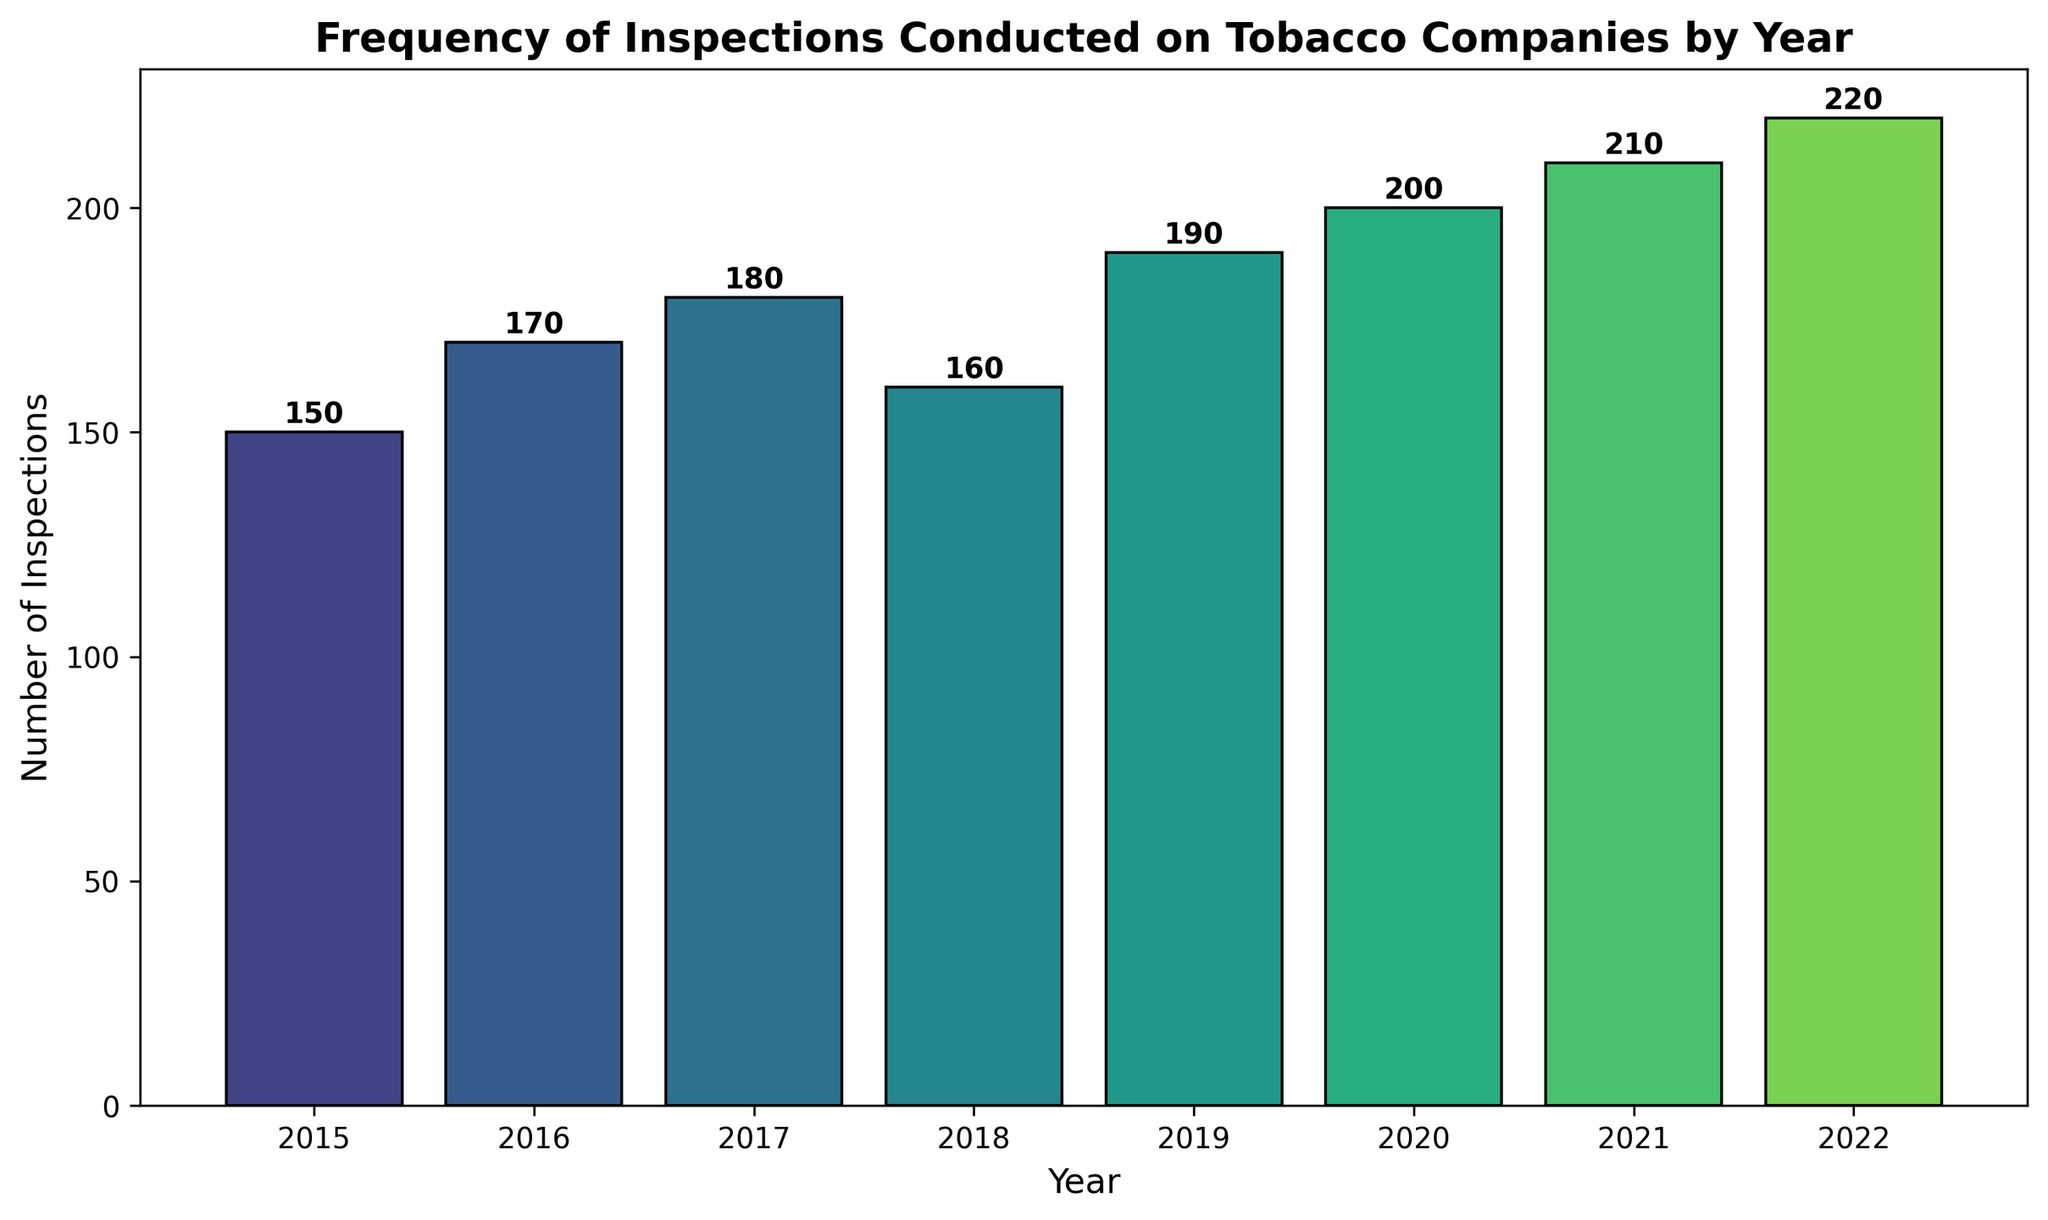What's the total number of inspections conducted over all years? Sum the inspections for each year: 150 + 170 + 180 + 160 + 190 + 200 + 210 + 220 = 1480
Answer: 1480 What's the average number of inspections conducted per year? Sum the total number of inspections (1480) and divide by the number of years (8): 1480 / 8 = 185
Answer: 185 In which year was the highest number of inspections conducted? Identify the highest bar in the chart. The tallest bar corresponds to the year 2022 with 220 inspections
Answer: 2022 How many more inspections were conducted in 2021 than in 2015? Subtract the number of inspections in 2015 from the number of inspections in 2021: 210 - 150 = 60
Answer: 60 What is the trend of the number of inspections from 2015 to 2022? Observe the general direction of the bars from left to right. The bars show a general increasing trend with minor fluctuations
Answer: Increasing trend Which year saw a decrease in the number of inspections compared to the previous year? Compare year-by-year bar heights. From 2017 to 2018, the inspections decreased from 180 to 160
Answer: 2018 Is there a consistent increase in the number of inspections each year? Analyze the annual changes in bar heights. Most years show an increase, but from 2017 to 2018, there is a decrease
Answer: No By how much did the number of inspections change from 2019 to 2020? Calculate the difference between the two years: 200 - 190 = 10
Answer: 10 Which year had inspections closest to the average number of inspections over all years? The average is 185. The bar for 2018 is closest to this value with 160 inspections
Answer: 2018 